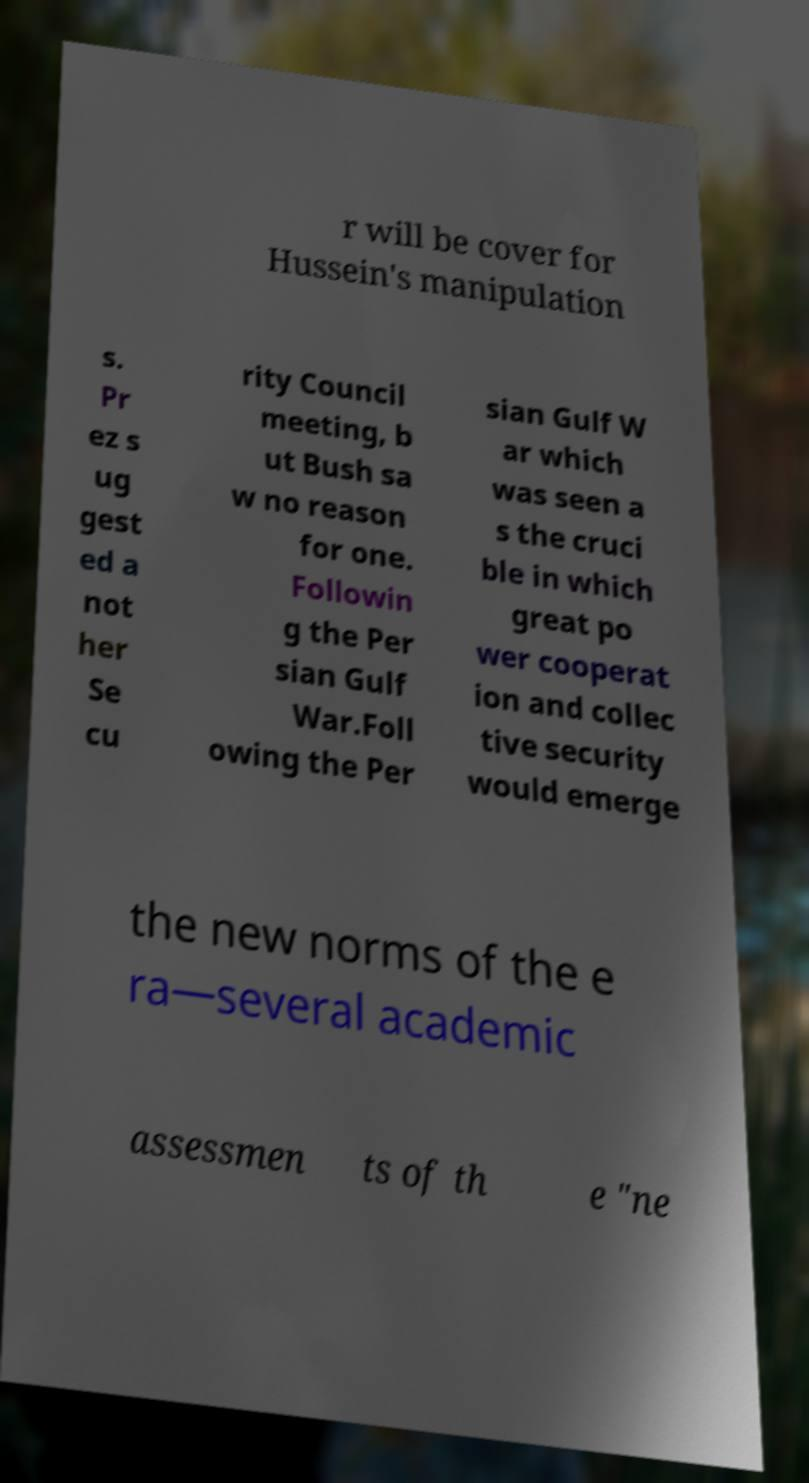Can you accurately transcribe the text from the provided image for me? r will be cover for Hussein's manipulation s. Pr ez s ug gest ed a not her Se cu rity Council meeting, b ut Bush sa w no reason for one. Followin g the Per sian Gulf War.Foll owing the Per sian Gulf W ar which was seen a s the cruci ble in which great po wer cooperat ion and collec tive security would emerge the new norms of the e ra—several academic assessmen ts of th e "ne 